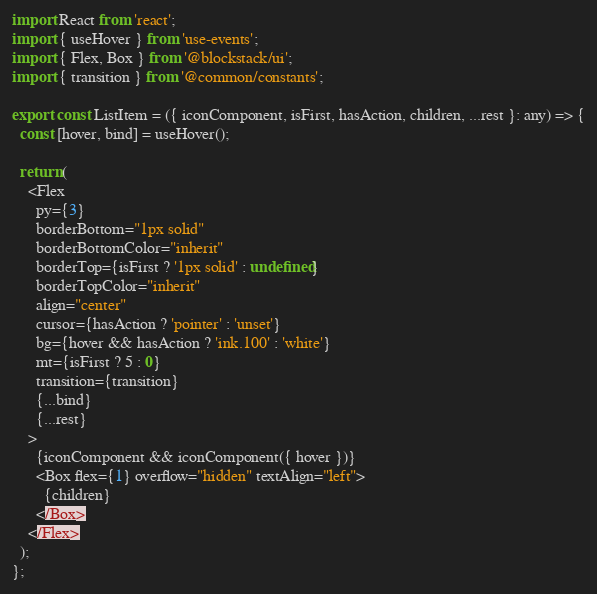Convert code to text. <code><loc_0><loc_0><loc_500><loc_500><_TypeScript_>import React from 'react';
import { useHover } from 'use-events';
import { Flex, Box } from '@blockstack/ui';
import { transition } from '@common/constants';

export const ListItem = ({ iconComponent, isFirst, hasAction, children, ...rest }: any) => {
  const [hover, bind] = useHover();

  return (
    <Flex
      py={3}
      borderBottom="1px solid"
      borderBottomColor="inherit"
      borderTop={isFirst ? '1px solid' : undefined}
      borderTopColor="inherit"
      align="center"
      cursor={hasAction ? 'pointer' : 'unset'}
      bg={hover && hasAction ? 'ink.100' : 'white'}
      mt={isFirst ? 5 : 0}
      transition={transition}
      {...bind}
      {...rest}
    >
      {iconComponent && iconComponent({ hover })}
      <Box flex={1} overflow="hidden" textAlign="left">
        {children}
      </Box>
    </Flex>
  );
};
</code> 